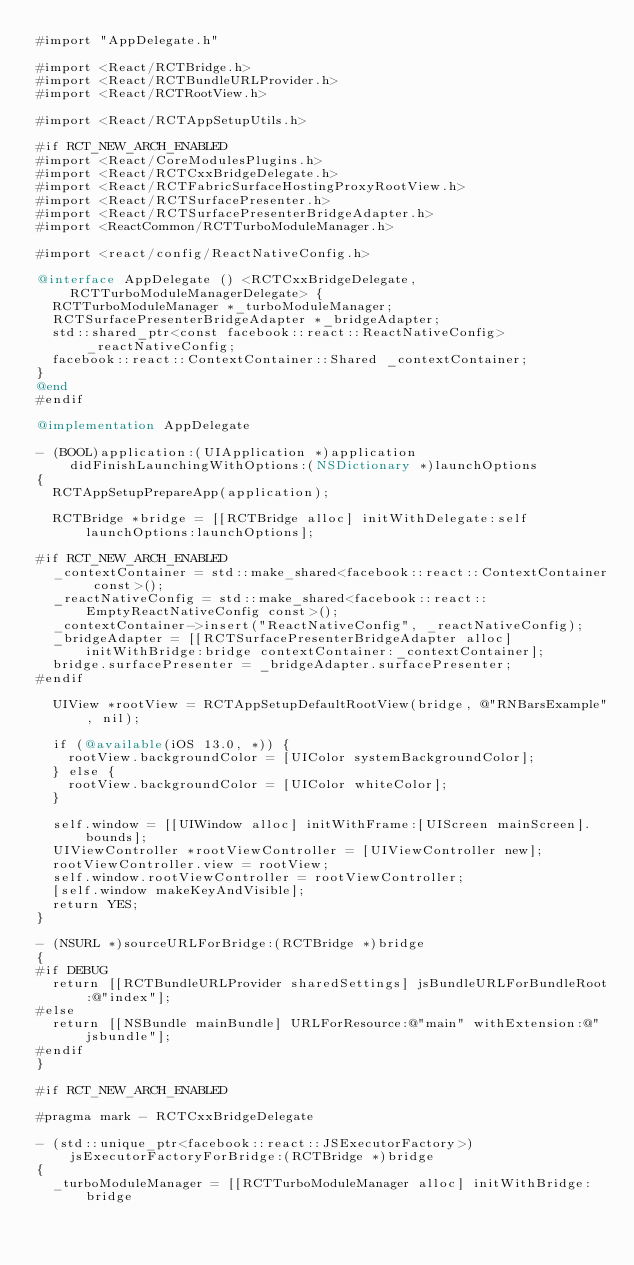Convert code to text. <code><loc_0><loc_0><loc_500><loc_500><_ObjectiveC_>#import "AppDelegate.h"

#import <React/RCTBridge.h>
#import <React/RCTBundleURLProvider.h>
#import <React/RCTRootView.h>

#import <React/RCTAppSetupUtils.h>

#if RCT_NEW_ARCH_ENABLED
#import <React/CoreModulesPlugins.h>
#import <React/RCTCxxBridgeDelegate.h>
#import <React/RCTFabricSurfaceHostingProxyRootView.h>
#import <React/RCTSurfacePresenter.h>
#import <React/RCTSurfacePresenterBridgeAdapter.h>
#import <ReactCommon/RCTTurboModuleManager.h>

#import <react/config/ReactNativeConfig.h>

@interface AppDelegate () <RCTCxxBridgeDelegate, RCTTurboModuleManagerDelegate> {
  RCTTurboModuleManager *_turboModuleManager;
  RCTSurfacePresenterBridgeAdapter *_bridgeAdapter;
  std::shared_ptr<const facebook::react::ReactNativeConfig> _reactNativeConfig;
  facebook::react::ContextContainer::Shared _contextContainer;
}
@end
#endif

@implementation AppDelegate

- (BOOL)application:(UIApplication *)application didFinishLaunchingWithOptions:(NSDictionary *)launchOptions
{
  RCTAppSetupPrepareApp(application);

  RCTBridge *bridge = [[RCTBridge alloc] initWithDelegate:self launchOptions:launchOptions];

#if RCT_NEW_ARCH_ENABLED
  _contextContainer = std::make_shared<facebook::react::ContextContainer const>();
  _reactNativeConfig = std::make_shared<facebook::react::EmptyReactNativeConfig const>();
  _contextContainer->insert("ReactNativeConfig", _reactNativeConfig);
  _bridgeAdapter = [[RCTSurfacePresenterBridgeAdapter alloc] initWithBridge:bridge contextContainer:_contextContainer];
  bridge.surfacePresenter = _bridgeAdapter.surfacePresenter;
#endif

  UIView *rootView = RCTAppSetupDefaultRootView(bridge, @"RNBarsExample", nil);

  if (@available(iOS 13.0, *)) {
    rootView.backgroundColor = [UIColor systemBackgroundColor];
  } else {
    rootView.backgroundColor = [UIColor whiteColor];
  }

  self.window = [[UIWindow alloc] initWithFrame:[UIScreen mainScreen].bounds];
  UIViewController *rootViewController = [UIViewController new];
  rootViewController.view = rootView;
  self.window.rootViewController = rootViewController;
  [self.window makeKeyAndVisible];
  return YES;
}

- (NSURL *)sourceURLForBridge:(RCTBridge *)bridge
{
#if DEBUG
  return [[RCTBundleURLProvider sharedSettings] jsBundleURLForBundleRoot:@"index"];
#else
  return [[NSBundle mainBundle] URLForResource:@"main" withExtension:@"jsbundle"];
#endif
}

#if RCT_NEW_ARCH_ENABLED

#pragma mark - RCTCxxBridgeDelegate

- (std::unique_ptr<facebook::react::JSExecutorFactory>)jsExecutorFactoryForBridge:(RCTBridge *)bridge
{
  _turboModuleManager = [[RCTTurboModuleManager alloc] initWithBridge:bridge</code> 